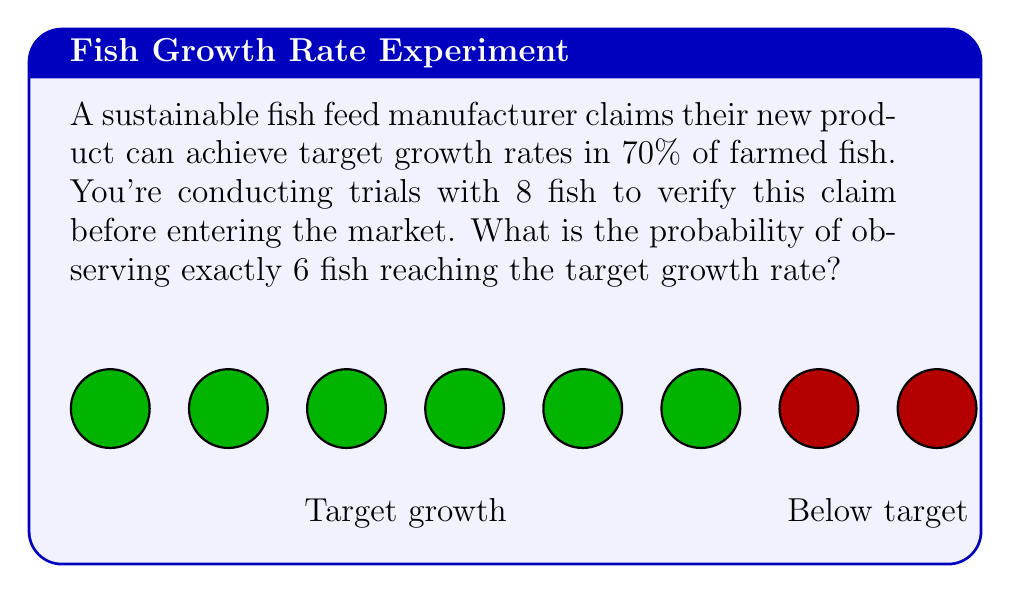Can you answer this question? To solve this problem, we can use the binomial probability formula:

$$ P(X = k) = \binom{n}{k} p^k (1-p)^{n-k} $$

Where:
- $n$ is the number of trials (8 fish)
- $k$ is the number of successes (6 fish reaching target growth)
- $p$ is the probability of success for each trial (70% or 0.7)

Step 1: Calculate the binomial coefficient
$$ \binom{8}{6} = \frac{8!}{6!(8-6)!} = \frac{8!}{6!2!} = 28 $$

Step 2: Substitute values into the formula
$$ P(X = 6) = 28 \cdot (0.7)^6 \cdot (1-0.7)^{8-6} $$

Step 3: Simplify
$$ P(X = 6) = 28 \cdot (0.7)^6 \cdot (0.3)^2 $$

Step 4: Calculate the result
$$ P(X = 6) = 28 \cdot 0.117649 \cdot 0.09 = 0.2966 $$

Therefore, the probability of observing exactly 6 out of 8 fish reaching the target growth rate is approximately 0.2966 or 29.66%.
Answer: 0.2966 